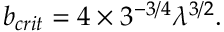<formula> <loc_0><loc_0><loc_500><loc_500>b _ { c r i t } = 4 \times 3 ^ { - 3 / 4 } \lambda ^ { 3 / 2 } .</formula> 